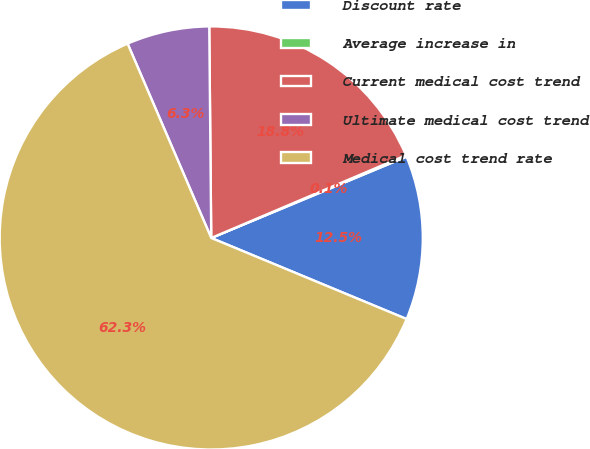Convert chart to OTSL. <chart><loc_0><loc_0><loc_500><loc_500><pie_chart><fcel>Discount rate<fcel>Average increase in<fcel>Current medical cost trend<fcel>Ultimate medical cost trend<fcel>Medical cost trend rate<nl><fcel>12.54%<fcel>0.11%<fcel>18.76%<fcel>6.32%<fcel>62.27%<nl></chart> 